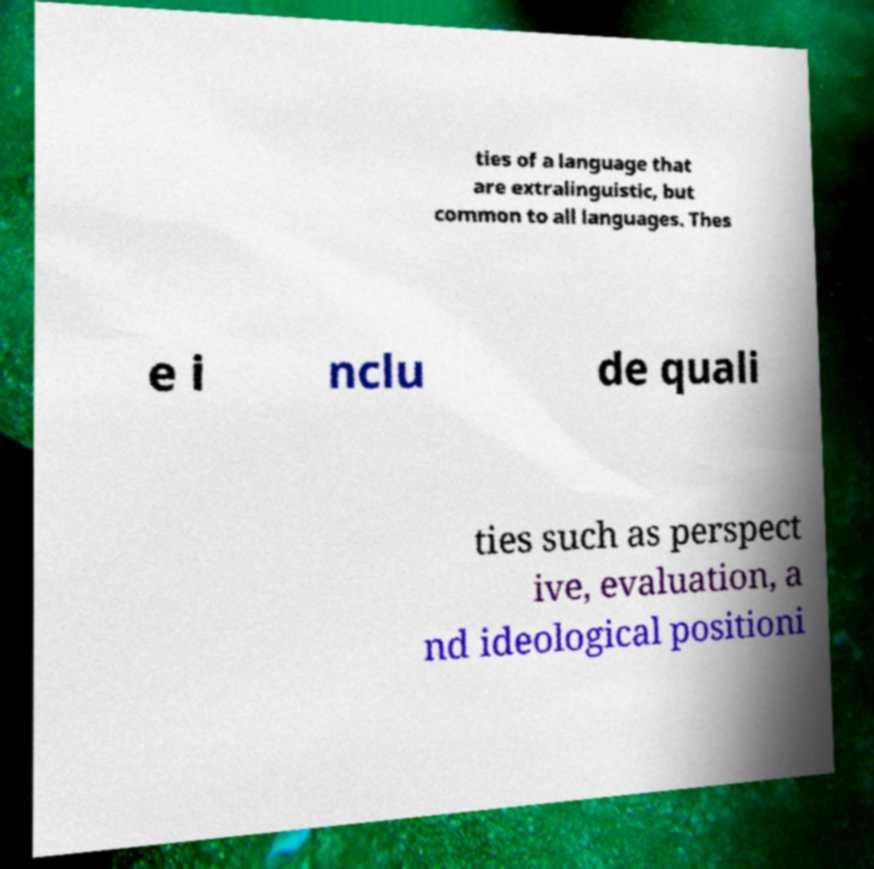I need the written content from this picture converted into text. Can you do that? ties of a language that are extralinguistic, but common to all languages. Thes e i nclu de quali ties such as perspect ive, evaluation, a nd ideological positioni 